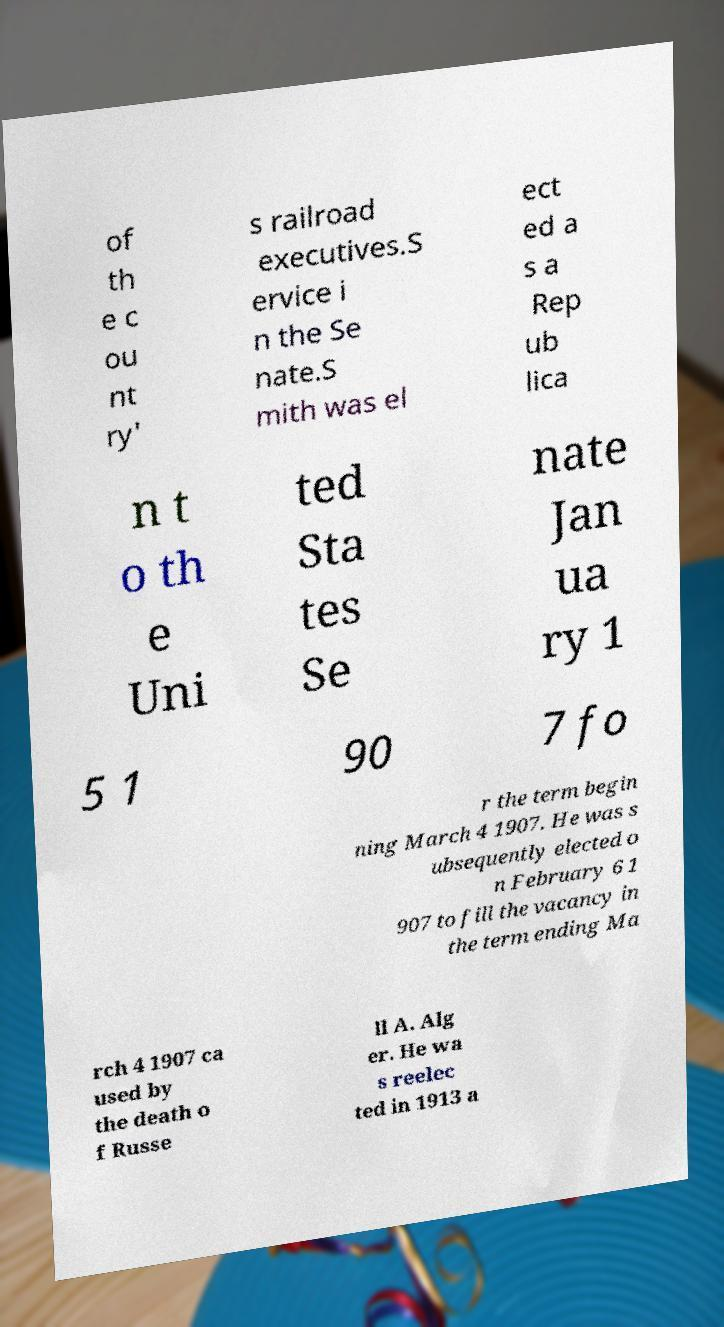Could you assist in decoding the text presented in this image and type it out clearly? of th e c ou nt ry' s railroad executives.S ervice i n the Se nate.S mith was el ect ed a s a Rep ub lica n t o th e Uni ted Sta tes Se nate Jan ua ry 1 5 1 90 7 fo r the term begin ning March 4 1907. He was s ubsequently elected o n February 6 1 907 to fill the vacancy in the term ending Ma rch 4 1907 ca used by the death o f Russe ll A. Alg er. He wa s reelec ted in 1913 a 